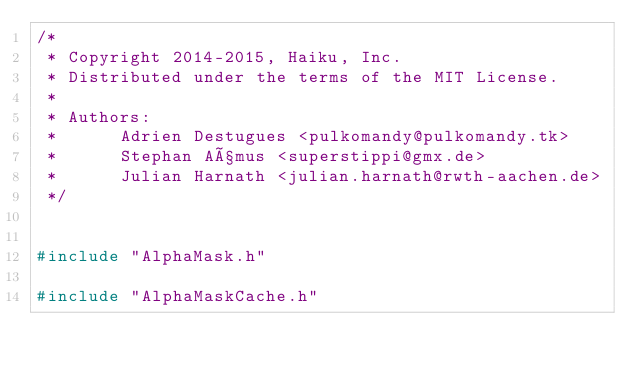<code> <loc_0><loc_0><loc_500><loc_500><_C++_>/*
 * Copyright 2014-2015, Haiku, Inc.
 * Distributed under the terms of the MIT License.
 *
 * Authors:
 *		Adrien Destugues <pulkomandy@pulkomandy.tk>
 *		Stephan Aßmus <superstippi@gmx.de>
 *		Julian Harnath <julian.harnath@rwth-aachen.de>
 */


#include "AlphaMask.h"

#include "AlphaMaskCache.h"</code> 